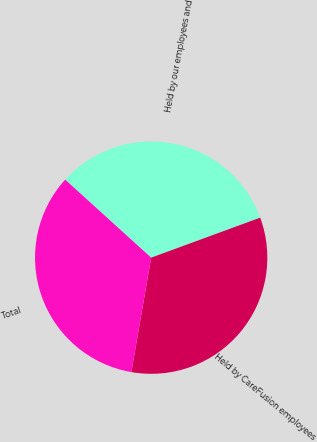Convert chart. <chart><loc_0><loc_0><loc_500><loc_500><pie_chart><fcel>Held by our employees and<fcel>Held by CareFusion employees<fcel>Total<nl><fcel>32.68%<fcel>33.33%<fcel>33.99%<nl></chart> 